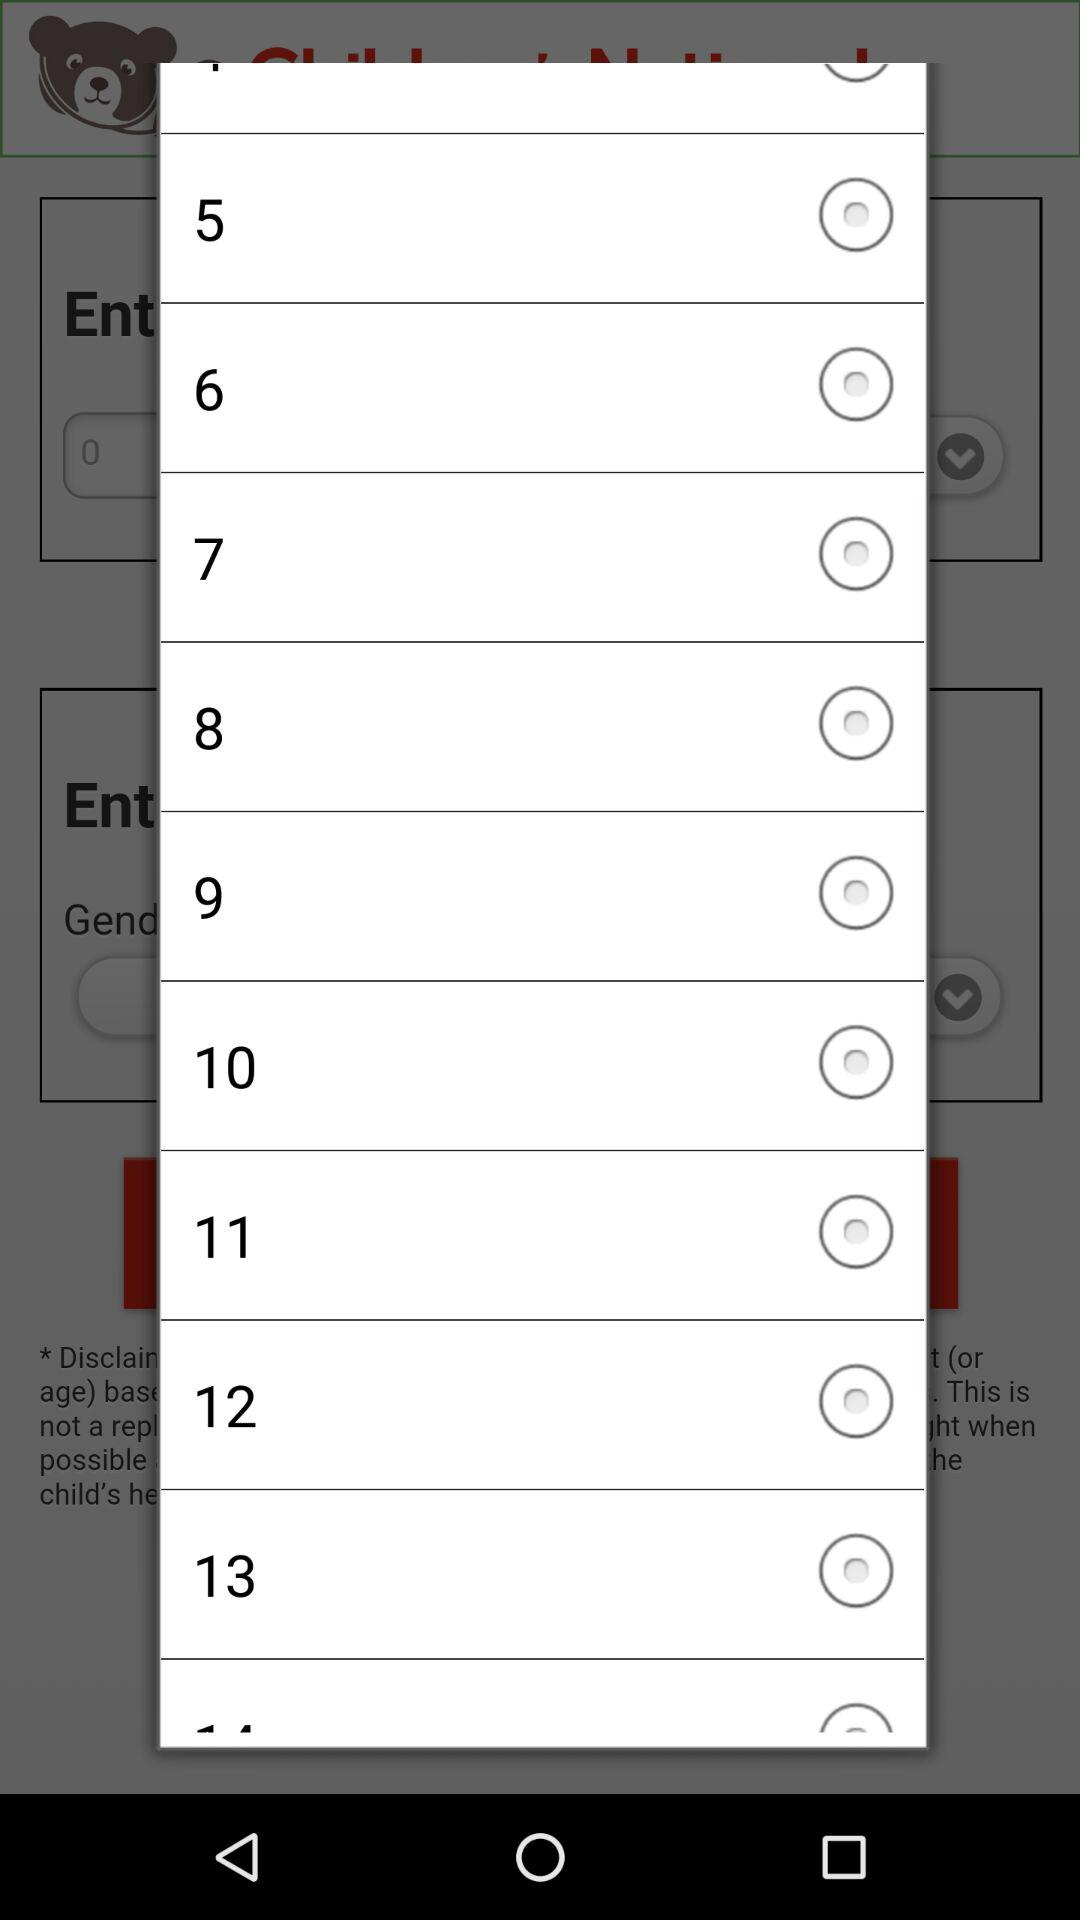Which gender is selected?
When the provided information is insufficient, respond with <no answer>. <no answer> 